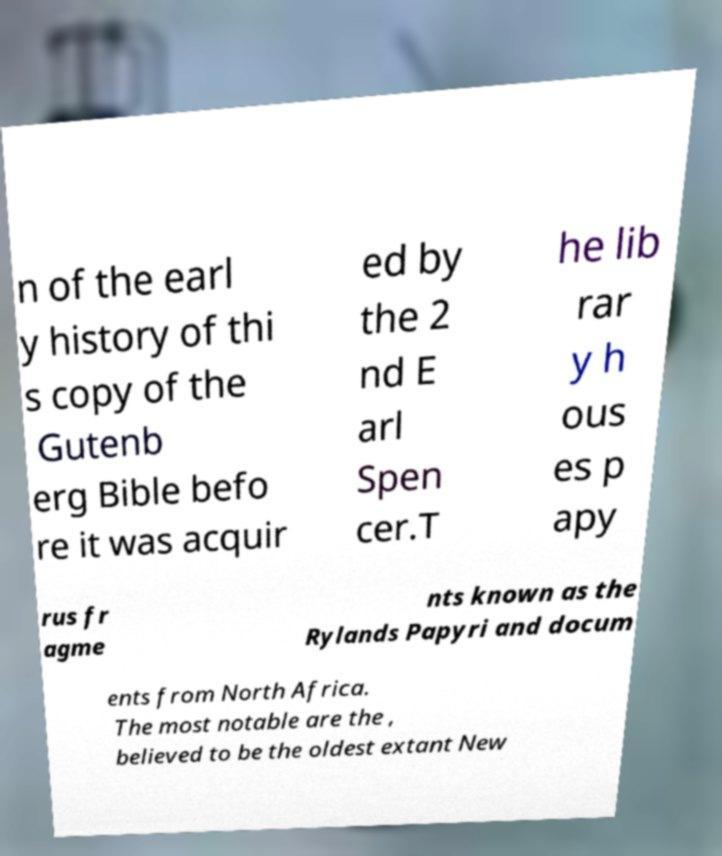Can you read and provide the text displayed in the image?This photo seems to have some interesting text. Can you extract and type it out for me? n of the earl y history of thi s copy of the Gutenb erg Bible befo re it was acquir ed by the 2 nd E arl Spen cer.T he lib rar y h ous es p apy rus fr agme nts known as the Rylands Papyri and docum ents from North Africa. The most notable are the , believed to be the oldest extant New 